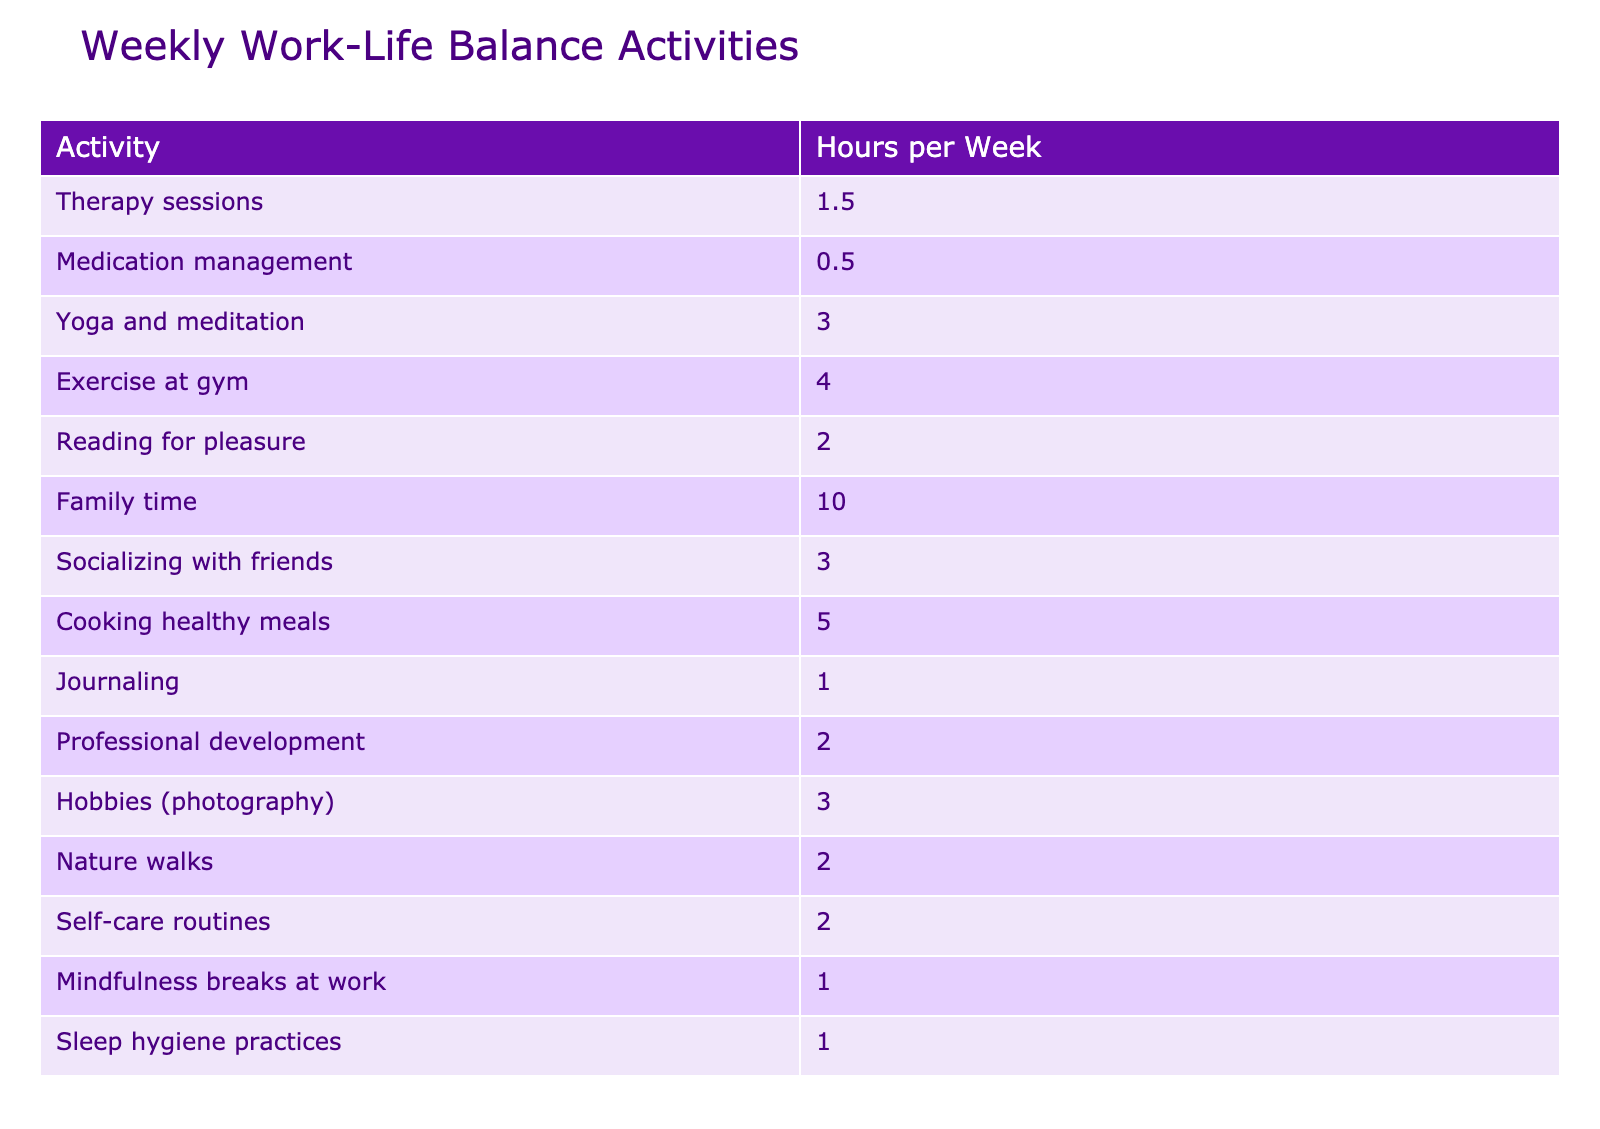What is the total number of hours dedicated to family time activities? The table indicates that family time accounts for 10 hours per week. There are no other activities listed under family time, so the total is simply the value given.
Answer: 10 What is the highest time allocation among all activities listed? Looking at the "Hours per Week" column, family time shows the highest value of 10 hours, which is greater than any other activity.
Answer: 10 How many hours per week are dedicated to self-care routines and mindfulness breaks combined? Self-care routines total 2 hours and mindfulness breaks at work total 1 hour. Adding these values together gives 2 + 1 = 3 hours.
Answer: 3 Which activities take more than 3 hours per week? Evaluating the "Hours per Week" column, the activities that take more than 3 hours are family time (10), cooking healthy meals (5), and exercise at the gym (4).
Answer: Family time, cooking healthy meals, exercise at the gym Is the time spent on yoga and meditation greater than time spent on professional development? Yoga and meditation totals 3 hours while professional development totals 2 hours. Since 3 is greater than 2, the statement is true.
Answer: Yes What is the average time spent on personal hobbies (photography and reading for pleasure)? The time allocated for hobbies (photography) is 3 hours and for reading for pleasure is 2 hours. Calculating the average involves adding these values (3 + 2 = 5) and dividing by the number of activities (2). The average is 5 / 2 = 2.5 hours.
Answer: 2.5 Are there any activities that require less than 2 hours per week? Looking at the "Hours per Week" column, therapy sessions (1.5), medication management (0.5), journaling (1), and mindfulness breaks (1) all require less than 2 hours. Hence the answer is yes.
Answer: Yes What is the total time spent on physical activities (yoga, gym, and nature walks)? Yoga and meditation take 3 hours, exercise at the gym takes 4 hours, and nature walks take 2 hours. Adding these values results in 3 + 4 + 2 = 9 hours spent on physical activities.
Answer: 9 